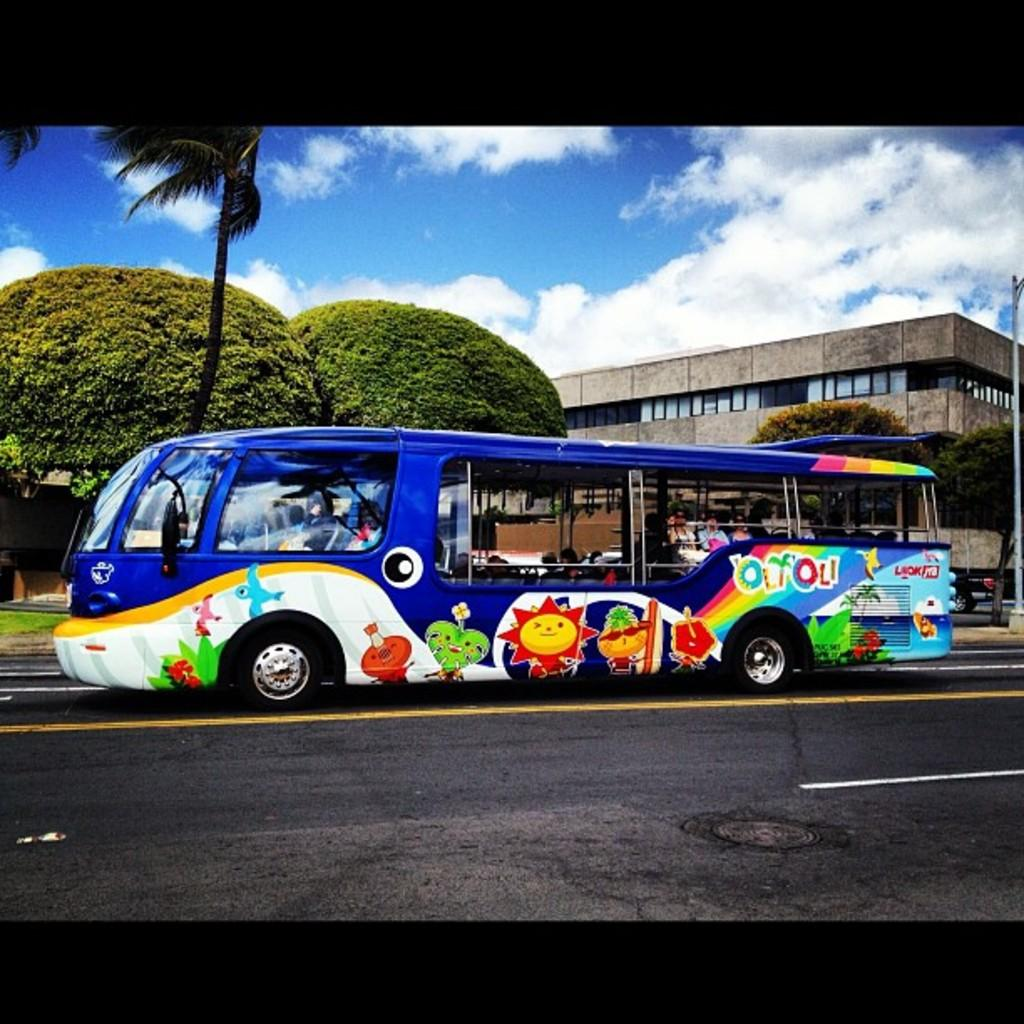<image>
Offer a succinct explanation of the picture presented. A very colorful bus with characters painted on it is on a road has the word olyoli written on the side of it 